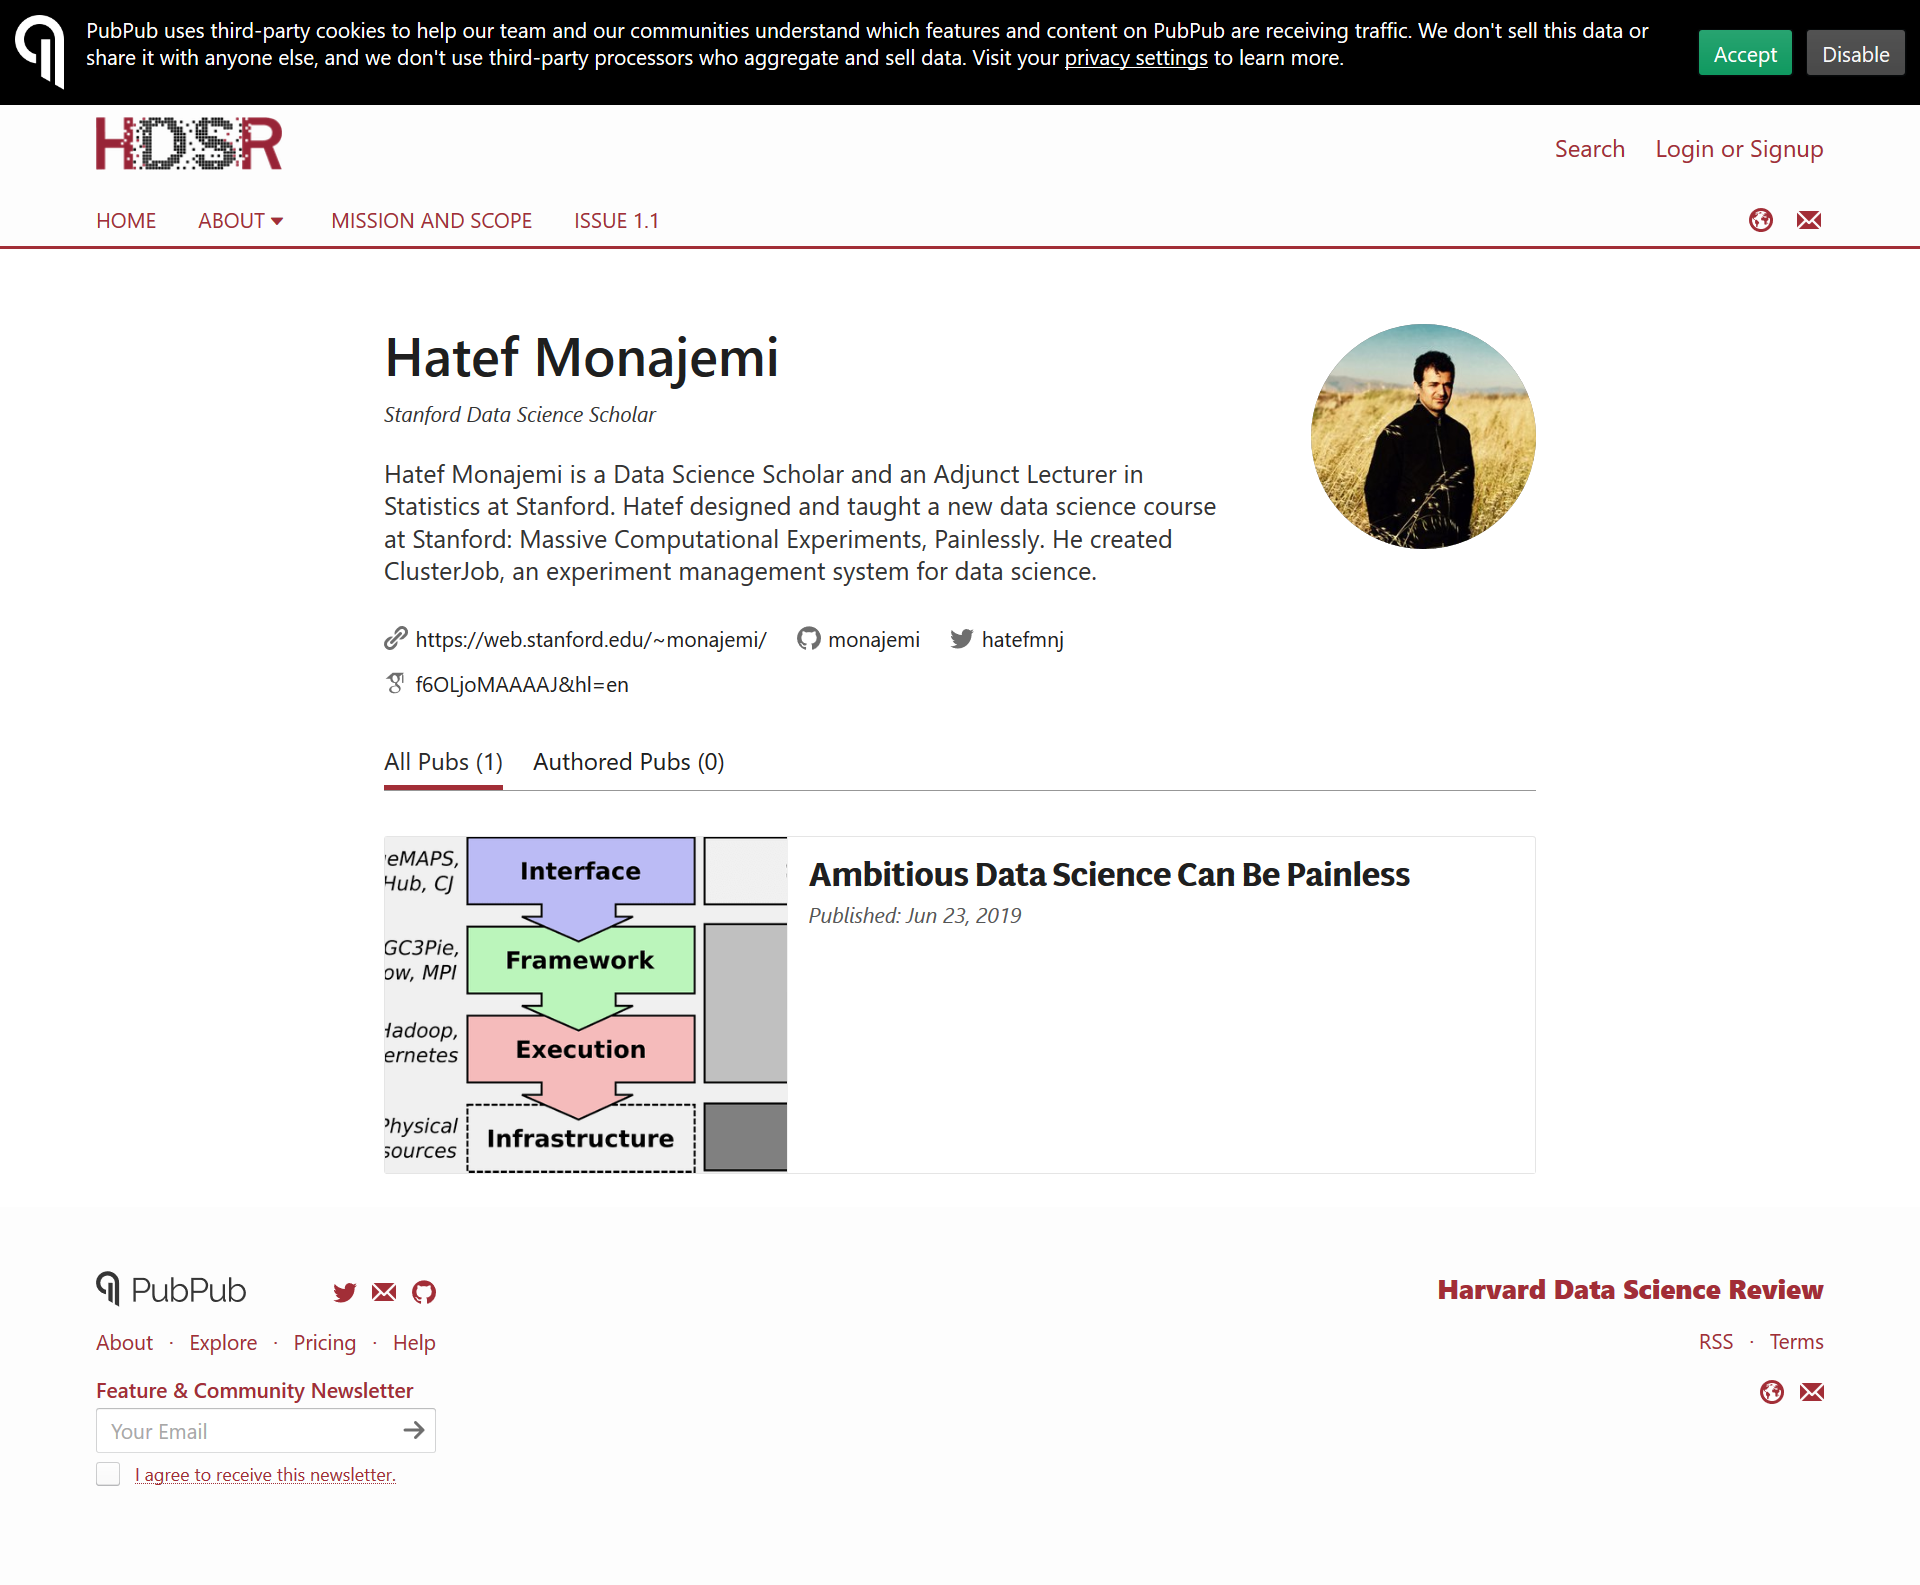Specify some key components in this picture. The process consists of four steps: Interface, Framework, Execution, and Infrastructure. Clusterjob is an experiment management system designed specifically for data science, which enables users to efficiently manage and optimize their experiments through the use of a cluster computing infrastructure. Hatef Monajemi is a Data Science Scholar and Adjunct in Statistics at Stanford University who is known for his expertise in the field of statistics and data science. 